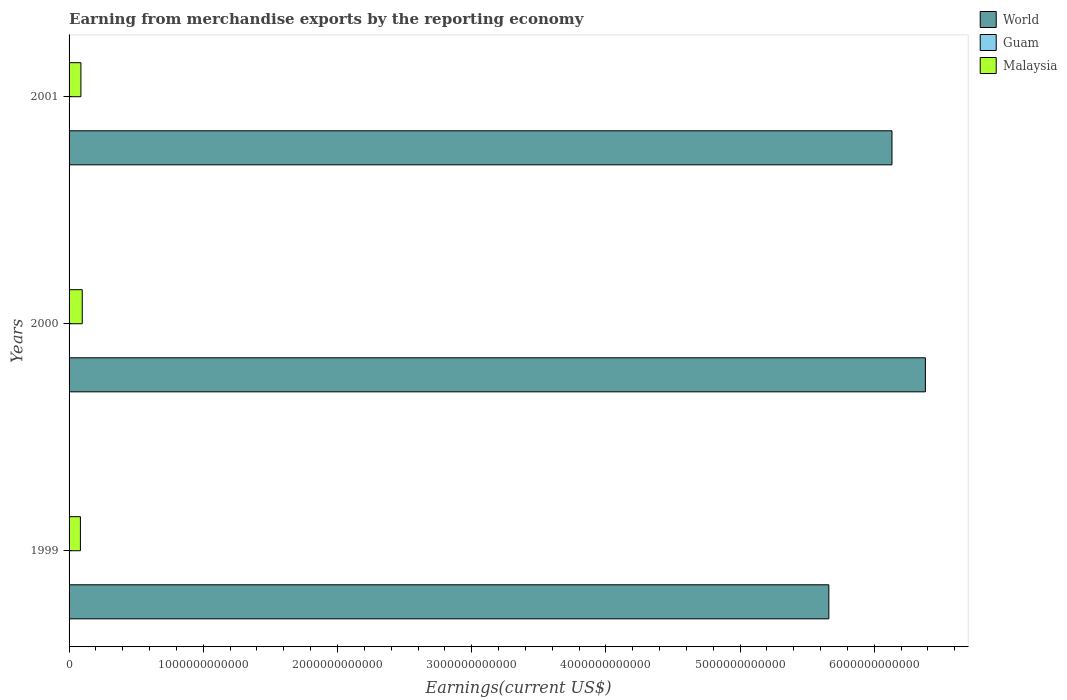How many groups of bars are there?
Your answer should be compact. 3. Are the number of bars per tick equal to the number of legend labels?
Keep it short and to the point. Yes. Are the number of bars on each tick of the Y-axis equal?
Keep it short and to the point. Yes. How many bars are there on the 3rd tick from the top?
Provide a short and direct response. 3. What is the label of the 1st group of bars from the top?
Ensure brevity in your answer.  2001. What is the amount earned from merchandise exports in Guam in 2000?
Ensure brevity in your answer.  1.11e+08. Across all years, what is the maximum amount earned from merchandise exports in Malaysia?
Your response must be concise. 9.82e+1. Across all years, what is the minimum amount earned from merchandise exports in Malaysia?
Provide a succinct answer. 8.46e+1. In which year was the amount earned from merchandise exports in World minimum?
Ensure brevity in your answer.  1999. What is the total amount earned from merchandise exports in Guam in the graph?
Your response must be concise. 2.43e+08. What is the difference between the amount earned from merchandise exports in World in 1999 and that in 2001?
Your response must be concise. -4.70e+11. What is the difference between the amount earned from merchandise exports in Malaysia in 1999 and the amount earned from merchandise exports in World in 2001?
Keep it short and to the point. -6.05e+12. What is the average amount earned from merchandise exports in World per year?
Offer a very short reply. 6.06e+12. In the year 2000, what is the difference between the amount earned from merchandise exports in World and amount earned from merchandise exports in Guam?
Keep it short and to the point. 6.38e+12. In how many years, is the amount earned from merchandise exports in Guam greater than 600000000000 US$?
Keep it short and to the point. 0. What is the ratio of the amount earned from merchandise exports in Guam in 2000 to that in 2001?
Your answer should be compact. 1.99. Is the amount earned from merchandise exports in Malaysia in 2000 less than that in 2001?
Keep it short and to the point. No. What is the difference between the highest and the second highest amount earned from merchandise exports in World?
Your answer should be compact. 2.49e+11. What is the difference between the highest and the lowest amount earned from merchandise exports in Guam?
Offer a terse response. 5.50e+07. In how many years, is the amount earned from merchandise exports in Malaysia greater than the average amount earned from merchandise exports in Malaysia taken over all years?
Your answer should be compact. 1. Is the sum of the amount earned from merchandise exports in World in 2000 and 2001 greater than the maximum amount earned from merchandise exports in Malaysia across all years?
Provide a succinct answer. Yes. What does the 2nd bar from the top in 2001 represents?
Offer a very short reply. Guam. What does the 1st bar from the bottom in 1999 represents?
Provide a succinct answer. World. Is it the case that in every year, the sum of the amount earned from merchandise exports in World and amount earned from merchandise exports in Malaysia is greater than the amount earned from merchandise exports in Guam?
Provide a succinct answer. Yes. Are all the bars in the graph horizontal?
Give a very brief answer. Yes. How many years are there in the graph?
Provide a succinct answer. 3. What is the difference between two consecutive major ticks on the X-axis?
Your response must be concise. 1.00e+12. Does the graph contain any zero values?
Ensure brevity in your answer.  No. Where does the legend appear in the graph?
Provide a short and direct response. Top right. How are the legend labels stacked?
Ensure brevity in your answer.  Vertical. What is the title of the graph?
Offer a terse response. Earning from merchandise exports by the reporting economy. Does "Sweden" appear as one of the legend labels in the graph?
Provide a short and direct response. No. What is the label or title of the X-axis?
Your response must be concise. Earnings(current US$). What is the label or title of the Y-axis?
Your answer should be compact. Years. What is the Earnings(current US$) of World in 1999?
Give a very brief answer. 5.66e+12. What is the Earnings(current US$) of Guam in 1999?
Your answer should be very brief. 7.68e+07. What is the Earnings(current US$) of Malaysia in 1999?
Give a very brief answer. 8.46e+1. What is the Earnings(current US$) of World in 2000?
Provide a short and direct response. 6.38e+12. What is the Earnings(current US$) in Guam in 2000?
Keep it short and to the point. 1.11e+08. What is the Earnings(current US$) of Malaysia in 2000?
Provide a short and direct response. 9.82e+1. What is the Earnings(current US$) of World in 2001?
Provide a short and direct response. 6.13e+12. What is the Earnings(current US$) of Guam in 2001?
Offer a terse response. 5.57e+07. What is the Earnings(current US$) of Malaysia in 2001?
Offer a terse response. 8.82e+1. Across all years, what is the maximum Earnings(current US$) in World?
Offer a terse response. 6.38e+12. Across all years, what is the maximum Earnings(current US$) in Guam?
Offer a very short reply. 1.11e+08. Across all years, what is the maximum Earnings(current US$) of Malaysia?
Your answer should be compact. 9.82e+1. Across all years, what is the minimum Earnings(current US$) of World?
Your answer should be very brief. 5.66e+12. Across all years, what is the minimum Earnings(current US$) in Guam?
Provide a short and direct response. 5.57e+07. Across all years, what is the minimum Earnings(current US$) of Malaysia?
Ensure brevity in your answer.  8.46e+1. What is the total Earnings(current US$) in World in the graph?
Provide a short and direct response. 1.82e+13. What is the total Earnings(current US$) of Guam in the graph?
Provide a succinct answer. 2.43e+08. What is the total Earnings(current US$) in Malaysia in the graph?
Your answer should be compact. 2.71e+11. What is the difference between the Earnings(current US$) in World in 1999 and that in 2000?
Provide a succinct answer. -7.19e+11. What is the difference between the Earnings(current US$) of Guam in 1999 and that in 2000?
Offer a terse response. -3.39e+07. What is the difference between the Earnings(current US$) of Malaysia in 1999 and that in 2000?
Ensure brevity in your answer.  -1.36e+1. What is the difference between the Earnings(current US$) in World in 1999 and that in 2001?
Provide a short and direct response. -4.70e+11. What is the difference between the Earnings(current US$) of Guam in 1999 and that in 2001?
Ensure brevity in your answer.  2.11e+07. What is the difference between the Earnings(current US$) in Malaysia in 1999 and that in 2001?
Your answer should be very brief. -3.65e+09. What is the difference between the Earnings(current US$) of World in 2000 and that in 2001?
Your answer should be compact. 2.49e+11. What is the difference between the Earnings(current US$) in Guam in 2000 and that in 2001?
Your answer should be compact. 5.50e+07. What is the difference between the Earnings(current US$) in Malaysia in 2000 and that in 2001?
Give a very brief answer. 9.95e+09. What is the difference between the Earnings(current US$) of World in 1999 and the Earnings(current US$) of Guam in 2000?
Keep it short and to the point. 5.66e+12. What is the difference between the Earnings(current US$) of World in 1999 and the Earnings(current US$) of Malaysia in 2000?
Offer a terse response. 5.56e+12. What is the difference between the Earnings(current US$) of Guam in 1999 and the Earnings(current US$) of Malaysia in 2000?
Offer a very short reply. -9.81e+1. What is the difference between the Earnings(current US$) of World in 1999 and the Earnings(current US$) of Guam in 2001?
Your answer should be very brief. 5.66e+12. What is the difference between the Earnings(current US$) of World in 1999 and the Earnings(current US$) of Malaysia in 2001?
Your answer should be compact. 5.57e+12. What is the difference between the Earnings(current US$) in Guam in 1999 and the Earnings(current US$) in Malaysia in 2001?
Offer a terse response. -8.81e+1. What is the difference between the Earnings(current US$) of World in 2000 and the Earnings(current US$) of Guam in 2001?
Offer a terse response. 6.38e+12. What is the difference between the Earnings(current US$) in World in 2000 and the Earnings(current US$) in Malaysia in 2001?
Provide a short and direct response. 6.29e+12. What is the difference between the Earnings(current US$) in Guam in 2000 and the Earnings(current US$) in Malaysia in 2001?
Make the answer very short. -8.81e+1. What is the average Earnings(current US$) of World per year?
Your answer should be very brief. 6.06e+12. What is the average Earnings(current US$) of Guam per year?
Make the answer very short. 8.10e+07. What is the average Earnings(current US$) of Malaysia per year?
Your answer should be compact. 9.03e+1. In the year 1999, what is the difference between the Earnings(current US$) of World and Earnings(current US$) of Guam?
Keep it short and to the point. 5.66e+12. In the year 1999, what is the difference between the Earnings(current US$) in World and Earnings(current US$) in Malaysia?
Keep it short and to the point. 5.58e+12. In the year 1999, what is the difference between the Earnings(current US$) of Guam and Earnings(current US$) of Malaysia?
Give a very brief answer. -8.45e+1. In the year 2000, what is the difference between the Earnings(current US$) in World and Earnings(current US$) in Guam?
Offer a very short reply. 6.38e+12. In the year 2000, what is the difference between the Earnings(current US$) of World and Earnings(current US$) of Malaysia?
Your answer should be compact. 6.28e+12. In the year 2000, what is the difference between the Earnings(current US$) of Guam and Earnings(current US$) of Malaysia?
Keep it short and to the point. -9.80e+1. In the year 2001, what is the difference between the Earnings(current US$) in World and Earnings(current US$) in Guam?
Provide a short and direct response. 6.13e+12. In the year 2001, what is the difference between the Earnings(current US$) in World and Earnings(current US$) in Malaysia?
Offer a terse response. 6.04e+12. In the year 2001, what is the difference between the Earnings(current US$) of Guam and Earnings(current US$) of Malaysia?
Your answer should be very brief. -8.81e+1. What is the ratio of the Earnings(current US$) of World in 1999 to that in 2000?
Your response must be concise. 0.89. What is the ratio of the Earnings(current US$) of Guam in 1999 to that in 2000?
Ensure brevity in your answer.  0.69. What is the ratio of the Earnings(current US$) in Malaysia in 1999 to that in 2000?
Give a very brief answer. 0.86. What is the ratio of the Earnings(current US$) in World in 1999 to that in 2001?
Provide a succinct answer. 0.92. What is the ratio of the Earnings(current US$) of Guam in 1999 to that in 2001?
Your answer should be compact. 1.38. What is the ratio of the Earnings(current US$) of Malaysia in 1999 to that in 2001?
Your answer should be compact. 0.96. What is the ratio of the Earnings(current US$) in World in 2000 to that in 2001?
Offer a terse response. 1.04. What is the ratio of the Earnings(current US$) of Guam in 2000 to that in 2001?
Your response must be concise. 1.99. What is the ratio of the Earnings(current US$) in Malaysia in 2000 to that in 2001?
Your answer should be compact. 1.11. What is the difference between the highest and the second highest Earnings(current US$) in World?
Your response must be concise. 2.49e+11. What is the difference between the highest and the second highest Earnings(current US$) in Guam?
Provide a short and direct response. 3.39e+07. What is the difference between the highest and the second highest Earnings(current US$) of Malaysia?
Make the answer very short. 9.95e+09. What is the difference between the highest and the lowest Earnings(current US$) of World?
Your answer should be compact. 7.19e+11. What is the difference between the highest and the lowest Earnings(current US$) in Guam?
Offer a terse response. 5.50e+07. What is the difference between the highest and the lowest Earnings(current US$) of Malaysia?
Provide a succinct answer. 1.36e+1. 